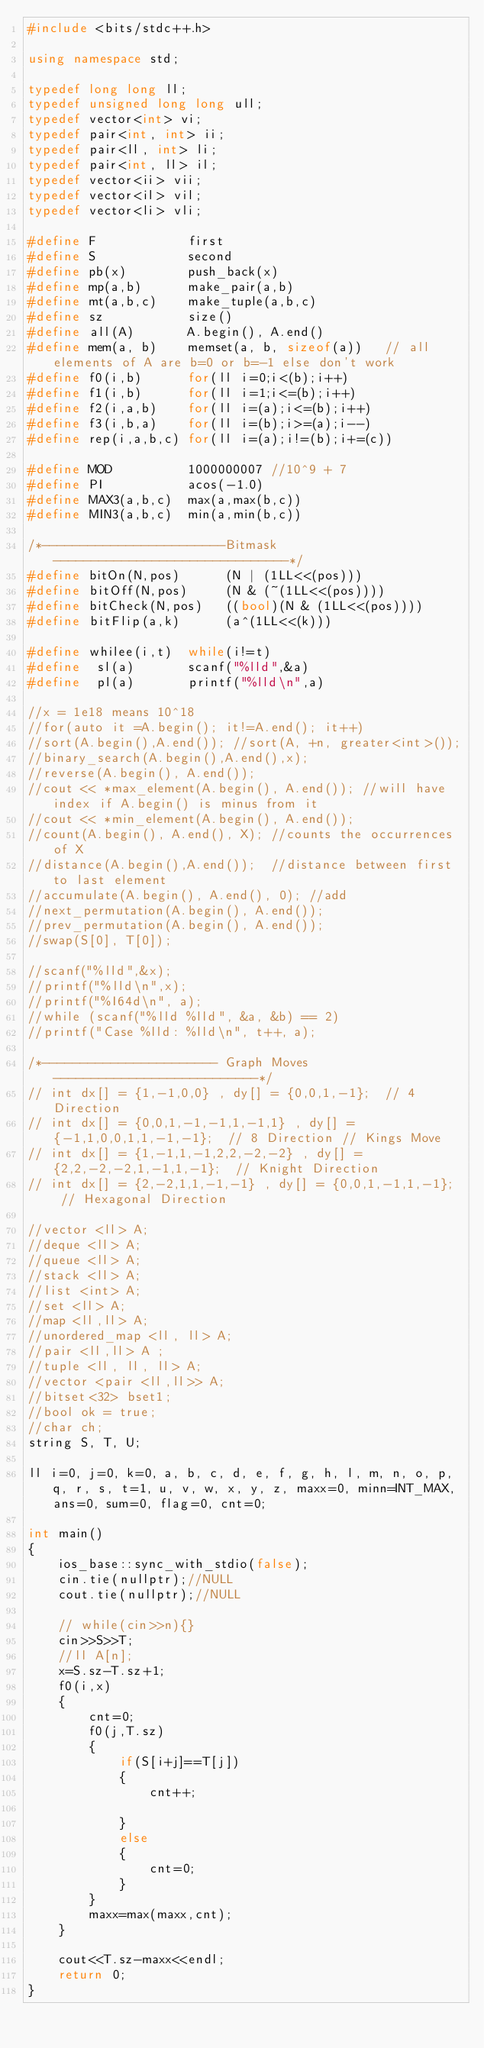Convert code to text. <code><loc_0><loc_0><loc_500><loc_500><_C++_>#include <bits/stdc++.h>

using namespace std;

typedef long long ll;
typedef unsigned long long ull;
typedef vector<int> vi;
typedef pair<int, int> ii;
typedef pair<ll, int> li;
typedef pair<int, ll> il;
typedef vector<ii> vii;
typedef vector<il> vil;
typedef vector<li> vli;

#define F            first
#define S            second
#define pb(x)        push_back(x)
#define mp(a,b)      make_pair(a,b)
#define mt(a,b,c)    make_tuple(a,b,c)
#define sz           size()
#define all(A)       A.begin(), A.end()
#define mem(a, b)    memset(a, b, sizeof(a))   // all elements of A are b=0 or b=-1 else don't work
#define f0(i,b)      for(ll i=0;i<(b);i++)
#define f1(i,b)      for(ll i=1;i<=(b);i++)
#define f2(i,a,b)    for(ll i=(a);i<=(b);i++)
#define f3(i,b,a)    for(ll i=(b);i>=(a);i--)
#define rep(i,a,b,c) for(ll i=(a);i!=(b);i+=(c))

#define MOD          1000000007 //10^9 + 7
#define PI           acos(-1.0)
#define MAX3(a,b,c)  max(a,max(b,c))
#define MIN3(a,b,c)  min(a,min(b,c))

/*------------------------Bitmask-------------------------------*/
#define bitOn(N,pos)      (N | (1LL<<(pos)))
#define bitOff(N,pos)     (N & (~(1LL<<(pos))))
#define bitCheck(N,pos)   ((bool)(N & (1LL<<(pos))))
#define bitFlip(a,k)      (a^(1LL<<(k)))

#define whilee(i,t)  while(i!=t)
#define  sl(a)       scanf("%lld",&a)
#define  pl(a)       printf("%lld\n",a)

//x = 1e18 means 10^18
//for(auto it =A.begin(); it!=A.end(); it++)
//sort(A.begin(),A.end()); //sort(A, +n, greater<int>());
//binary_search(A.begin(),A.end(),x);
//reverse(A.begin(), A.end());
//cout << *max_element(A.begin(), A.end()); //will have index if A.begin() is minus from it
//cout << *min_element(A.begin(), A.end());
//count(A.begin(), A.end(), X); //counts the occurrences of X
//distance(A.begin(),A.end());  //distance between first to last element
//accumulate(A.begin(), A.end(), 0); //add
//next_permutation(A.begin(), A.end());
//prev_permutation(A.begin(), A.end());
//swap(S[0], T[0]);

//scanf("%lld",&x);
//printf("%lld\n",x);
//printf("%I64d\n", a);
//while (scanf("%lld %lld", &a, &b) == 2)
//printf("Case %lld: %lld\n", t++, a);

/*----------------------- Graph Moves---------------------------*/
// int dx[] = {1,-1,0,0} , dy[] = {0,0,1,-1};  // 4 Direction
// int dx[] = {0,0,1,-1,-1,1,-1,1} , dy[] = {-1,1,0,0,1,1,-1,-1};  // 8 Direction // Kings Move
// int dx[] = {1,-1,1,-1,2,2,-2,-2} , dy[] = {2,2,-2,-2,1,-1,1,-1};  // Knight Direction
// int dx[] = {2,-2,1,1,-1,-1} , dy[] = {0,0,1,-1,1,-1};  // Hexagonal Direction

//vector <ll> A;
//deque <ll> A;
//queue <ll> A;
//stack <ll> A;
//list <int> A;
//set <ll> A;
//map <ll,ll> A;
//unordered_map <ll, ll> A;
//pair <ll,ll> A ;
//tuple <ll, ll, ll> A;
//vector <pair <ll,ll>> A;
//bitset<32> bset1;
//bool ok = true;
//char ch;
string S, T, U;

ll i=0, j=0, k=0, a, b, c, d, e, f, g, h, l, m, n, o, p, q, r, s, t=1, u, v, w, x, y, z, maxx=0, minn=INT_MAX, ans=0, sum=0, flag=0, cnt=0;

int main()
{
    ios_base::sync_with_stdio(false);
    cin.tie(nullptr);//NULL
    cout.tie(nullptr);//NULL

    // while(cin>>n){}
    cin>>S>>T;
    //ll A[n];
    x=S.sz-T.sz+1;
    f0(i,x)
    {
        cnt=0;
        f0(j,T.sz)
        {
            if(S[i+j]==T[j])
            {
                cnt++;

            }
            else
            {
                cnt=0;
            }
        }
        maxx=max(maxx,cnt);
    }

    cout<<T.sz-maxx<<endl;
    return 0;
}
</code> 